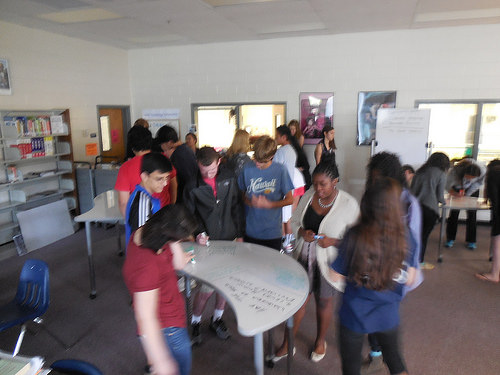<image>
Can you confirm if the lady is on the table? No. The lady is not positioned on the table. They may be near each other, but the lady is not supported by or resting on top of the table. 